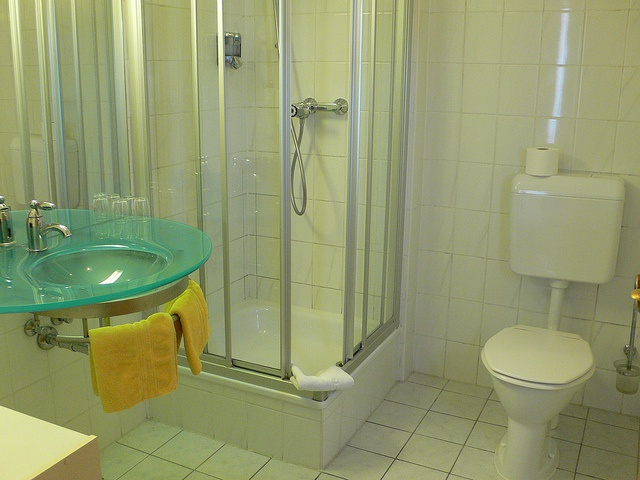Describe the objects in this image and their specific colors. I can see toilet in tan, olive, darkgray, and gray tones and sink in tan, green, turquoise, and ivory tones in this image. 